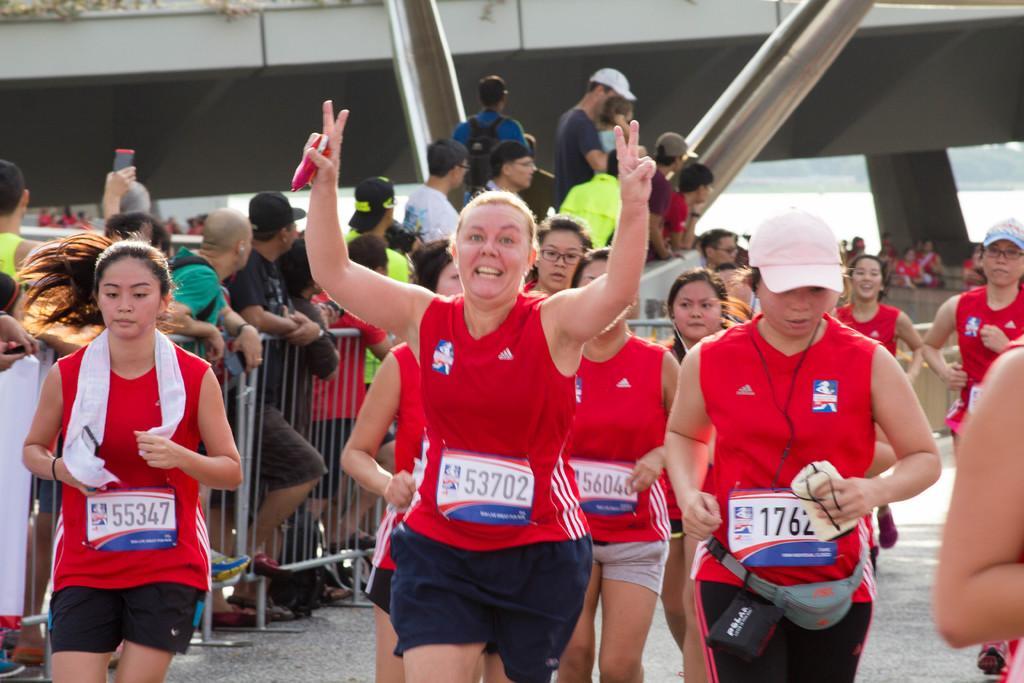Describe this image in one or two sentences. In this image, people in red color shirts are running, and in the background there are group of people standing, trees, water, iron grills, building. 